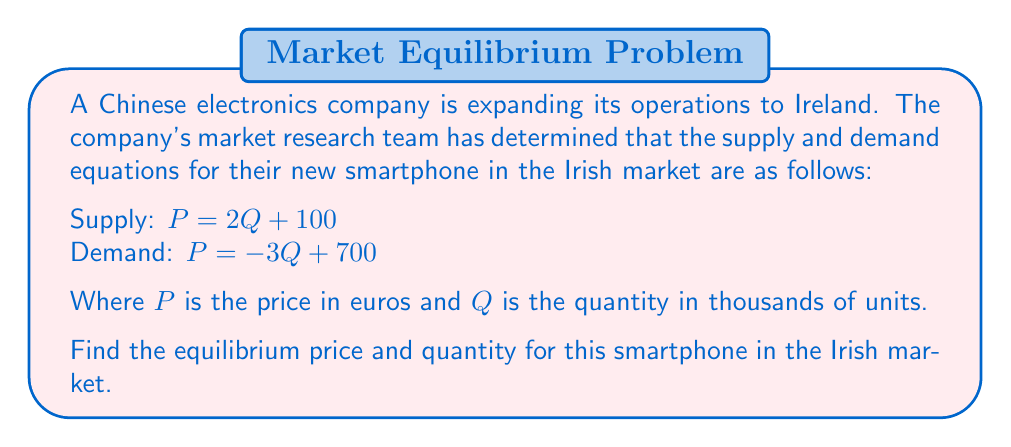Could you help me with this problem? To find the equilibrium price and quantity, we need to solve for the point where the supply and demand curves intersect. This involves setting the two equations equal to each other and solving for Q.

1. Set the supply and demand equations equal to each other:
   $2Q + 100 = -3Q + 700$

2. Solve for Q:
   $2Q + 3Q = 700 - 100$
   $5Q = 600$
   $Q = 120$

3. Now that we know the equilibrium quantity, we can substitute this value into either the supply or demand equation to find the equilibrium price. Let's use the supply equation:

   $P = 2Q + 100$
   $P = 2(120) + 100$
   $P = 240 + 100 = 340$

4. Therefore, the equilibrium point is (120, 340), where:
   - Q = 120 thousand units
   - P = €340

This means that at equilibrium, 120,000 smartphones will be sold at a price of €340 each.

[asy]
import graph;
size(200,200);
real f(real x) {return 2x + 100;}
real g(real x) {return -3x + 700;}
xaxis("Q (thousands)", 0, 250, Arrow);
yaxis("P (euros)", 0, 800, Arrow);
draw(graph(f,0,250));
draw(graph(g,0,233.33));
dot((120,340));
label("Equilibrium",(120,340),NE);
label("Supply",(200,f(200)),E);
label("Demand",(200,g(200)),E);
[/asy]
Answer: (120, 340) 